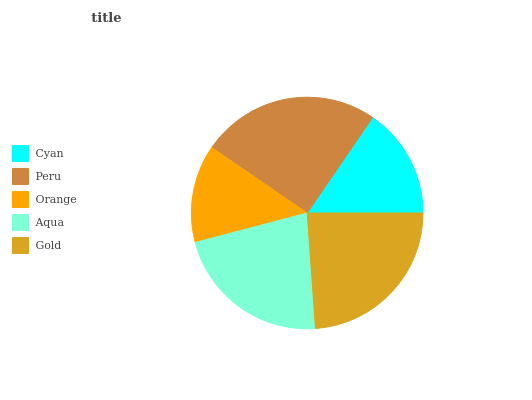Is Orange the minimum?
Answer yes or no. Yes. Is Peru the maximum?
Answer yes or no. Yes. Is Peru the minimum?
Answer yes or no. No. Is Orange the maximum?
Answer yes or no. No. Is Peru greater than Orange?
Answer yes or no. Yes. Is Orange less than Peru?
Answer yes or no. Yes. Is Orange greater than Peru?
Answer yes or no. No. Is Peru less than Orange?
Answer yes or no. No. Is Aqua the high median?
Answer yes or no. Yes. Is Aqua the low median?
Answer yes or no. Yes. Is Cyan the high median?
Answer yes or no. No. Is Peru the low median?
Answer yes or no. No. 